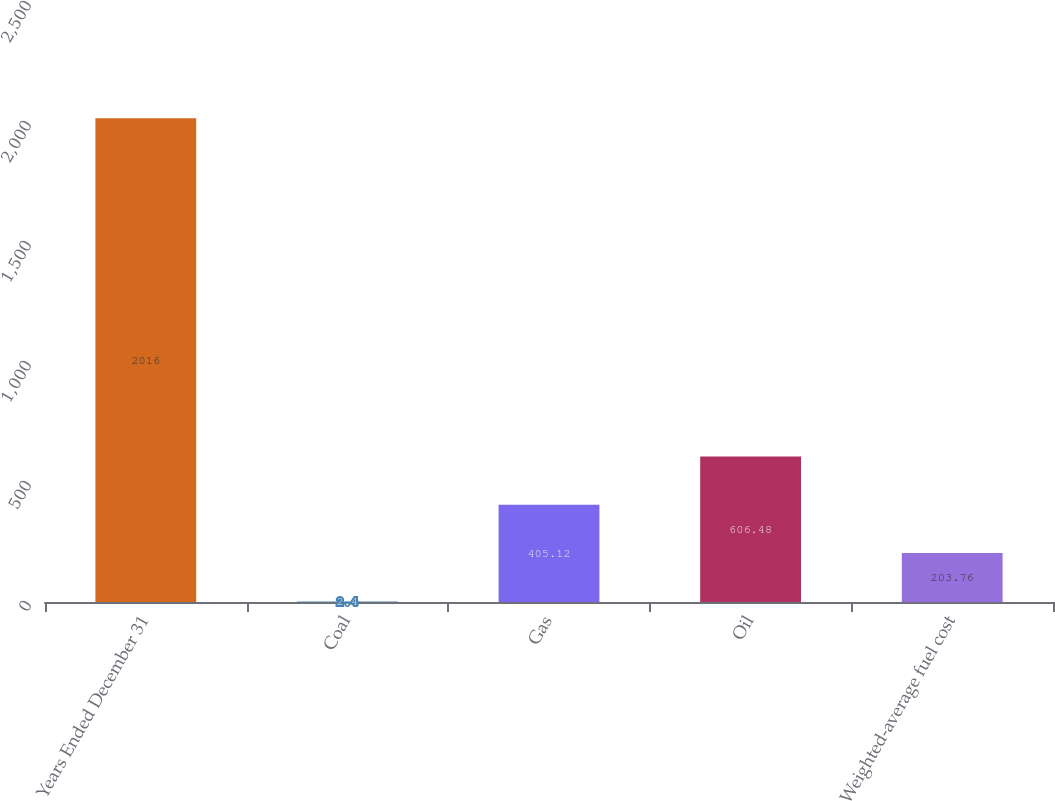Convert chart. <chart><loc_0><loc_0><loc_500><loc_500><bar_chart><fcel>Years Ended December 31<fcel>Coal<fcel>Gas<fcel>Oil<fcel>Weighted-average fuel cost<nl><fcel>2016<fcel>2.4<fcel>405.12<fcel>606.48<fcel>203.76<nl></chart> 